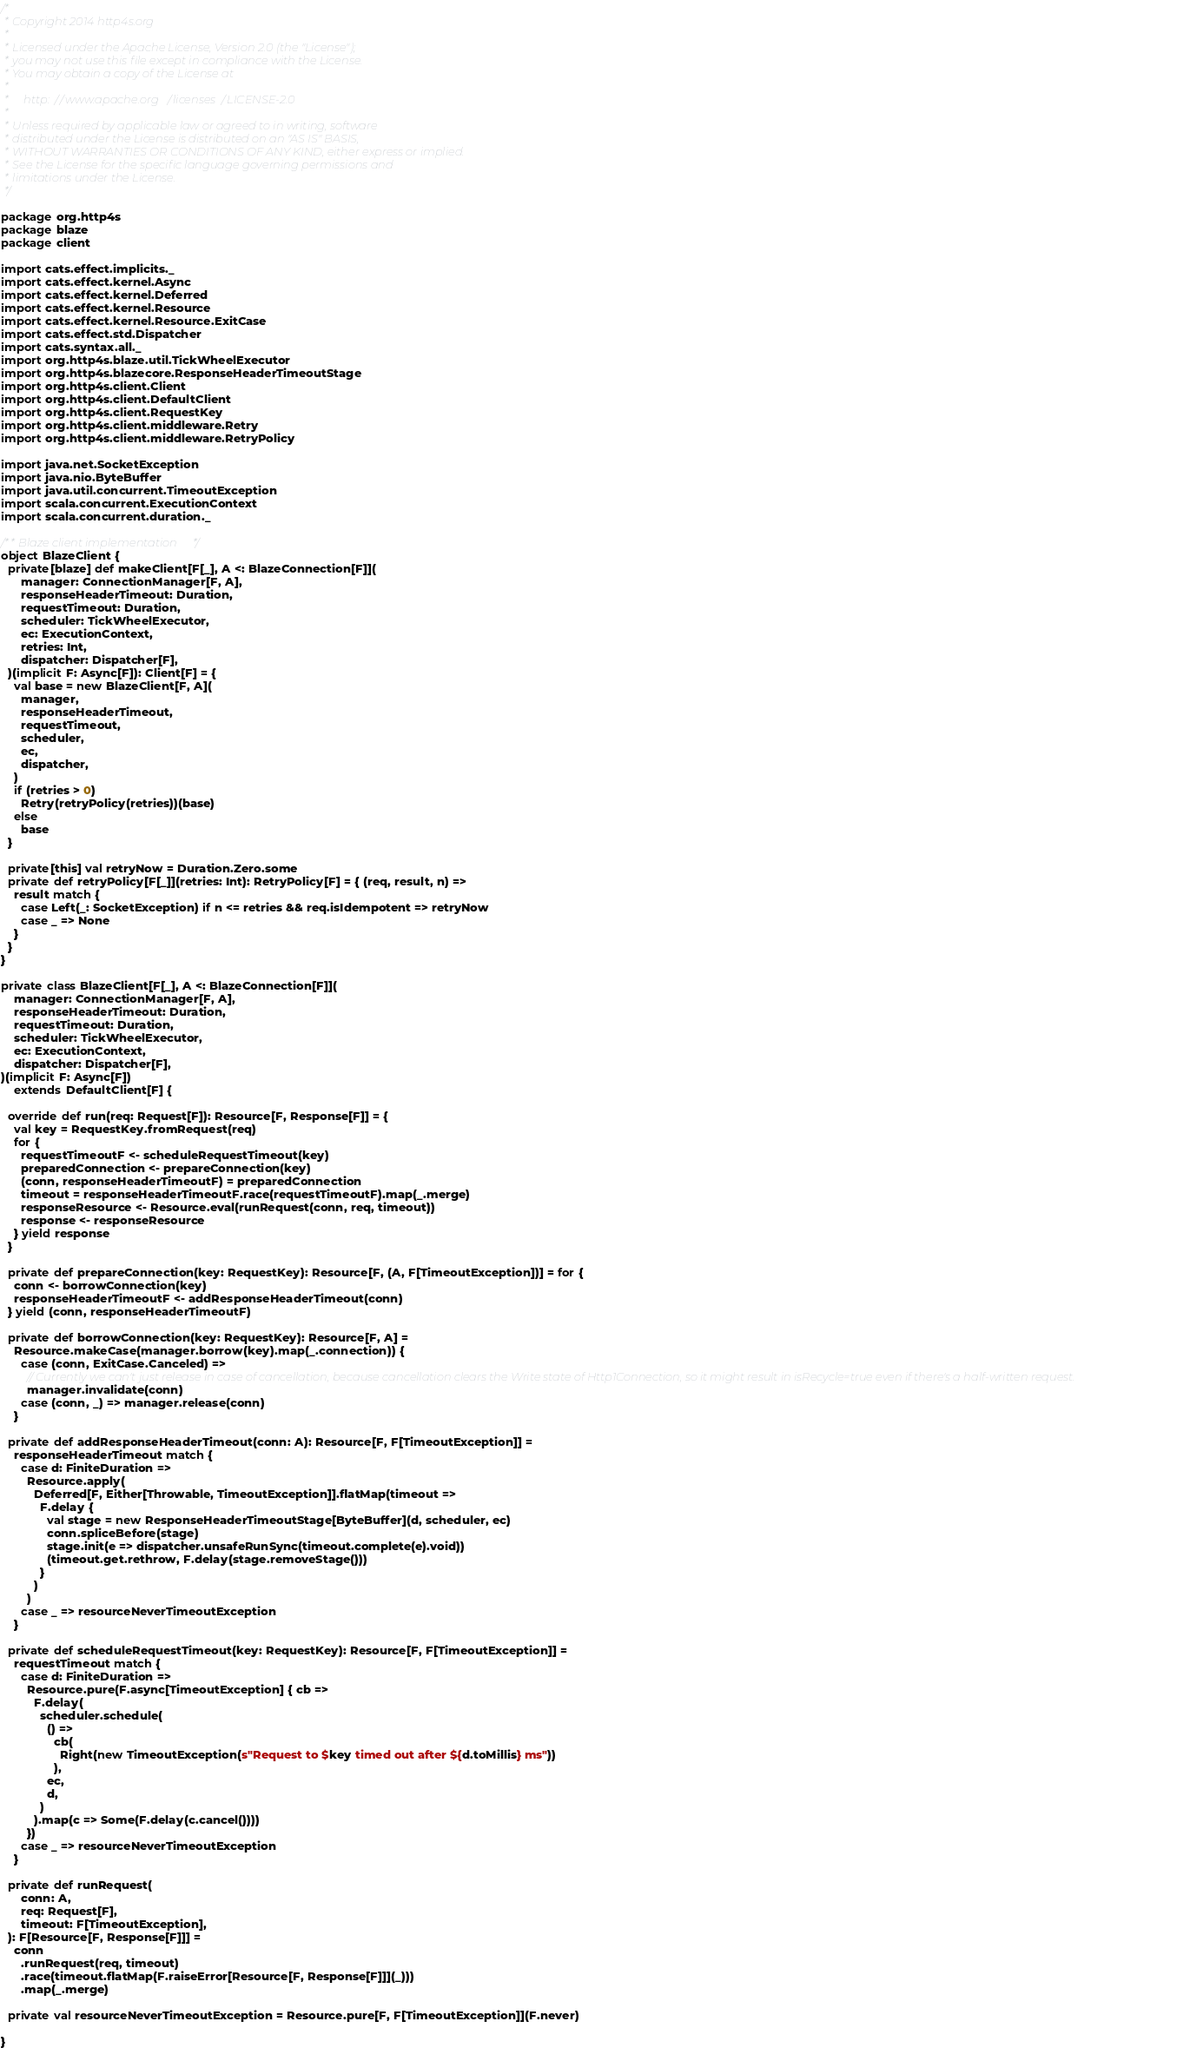Convert code to text. <code><loc_0><loc_0><loc_500><loc_500><_Scala_>/*
 * Copyright 2014 http4s.org
 *
 * Licensed under the Apache License, Version 2.0 (the "License");
 * you may not use this file except in compliance with the License.
 * You may obtain a copy of the License at
 *
 *     http://www.apache.org/licenses/LICENSE-2.0
 *
 * Unless required by applicable law or agreed to in writing, software
 * distributed under the License is distributed on an "AS IS" BASIS,
 * WITHOUT WARRANTIES OR CONDITIONS OF ANY KIND, either express or implied.
 * See the License for the specific language governing permissions and
 * limitations under the License.
 */

package org.http4s
package blaze
package client

import cats.effect.implicits._
import cats.effect.kernel.Async
import cats.effect.kernel.Deferred
import cats.effect.kernel.Resource
import cats.effect.kernel.Resource.ExitCase
import cats.effect.std.Dispatcher
import cats.syntax.all._
import org.http4s.blaze.util.TickWheelExecutor
import org.http4s.blazecore.ResponseHeaderTimeoutStage
import org.http4s.client.Client
import org.http4s.client.DefaultClient
import org.http4s.client.RequestKey
import org.http4s.client.middleware.Retry
import org.http4s.client.middleware.RetryPolicy

import java.net.SocketException
import java.nio.ByteBuffer
import java.util.concurrent.TimeoutException
import scala.concurrent.ExecutionContext
import scala.concurrent.duration._

/** Blaze client implementation */
object BlazeClient {
  private[blaze] def makeClient[F[_], A <: BlazeConnection[F]](
      manager: ConnectionManager[F, A],
      responseHeaderTimeout: Duration,
      requestTimeout: Duration,
      scheduler: TickWheelExecutor,
      ec: ExecutionContext,
      retries: Int,
      dispatcher: Dispatcher[F],
  )(implicit F: Async[F]): Client[F] = {
    val base = new BlazeClient[F, A](
      manager,
      responseHeaderTimeout,
      requestTimeout,
      scheduler,
      ec,
      dispatcher,
    )
    if (retries > 0)
      Retry(retryPolicy(retries))(base)
    else
      base
  }

  private[this] val retryNow = Duration.Zero.some
  private def retryPolicy[F[_]](retries: Int): RetryPolicy[F] = { (req, result, n) =>
    result match {
      case Left(_: SocketException) if n <= retries && req.isIdempotent => retryNow
      case _ => None
    }
  }
}

private class BlazeClient[F[_], A <: BlazeConnection[F]](
    manager: ConnectionManager[F, A],
    responseHeaderTimeout: Duration,
    requestTimeout: Duration,
    scheduler: TickWheelExecutor,
    ec: ExecutionContext,
    dispatcher: Dispatcher[F],
)(implicit F: Async[F])
    extends DefaultClient[F] {

  override def run(req: Request[F]): Resource[F, Response[F]] = {
    val key = RequestKey.fromRequest(req)
    for {
      requestTimeoutF <- scheduleRequestTimeout(key)
      preparedConnection <- prepareConnection(key)
      (conn, responseHeaderTimeoutF) = preparedConnection
      timeout = responseHeaderTimeoutF.race(requestTimeoutF).map(_.merge)
      responseResource <- Resource.eval(runRequest(conn, req, timeout))
      response <- responseResource
    } yield response
  }

  private def prepareConnection(key: RequestKey): Resource[F, (A, F[TimeoutException])] = for {
    conn <- borrowConnection(key)
    responseHeaderTimeoutF <- addResponseHeaderTimeout(conn)
  } yield (conn, responseHeaderTimeoutF)

  private def borrowConnection(key: RequestKey): Resource[F, A] =
    Resource.makeCase(manager.borrow(key).map(_.connection)) {
      case (conn, ExitCase.Canceled) =>
        // Currently we can't just release in case of cancellation, because cancellation clears the Write state of Http1Connection, so it might result in isRecycle=true even if there's a half-written request.
        manager.invalidate(conn)
      case (conn, _) => manager.release(conn)
    }

  private def addResponseHeaderTimeout(conn: A): Resource[F, F[TimeoutException]] =
    responseHeaderTimeout match {
      case d: FiniteDuration =>
        Resource.apply(
          Deferred[F, Either[Throwable, TimeoutException]].flatMap(timeout =>
            F.delay {
              val stage = new ResponseHeaderTimeoutStage[ByteBuffer](d, scheduler, ec)
              conn.spliceBefore(stage)
              stage.init(e => dispatcher.unsafeRunSync(timeout.complete(e).void))
              (timeout.get.rethrow, F.delay(stage.removeStage()))
            }
          )
        )
      case _ => resourceNeverTimeoutException
    }

  private def scheduleRequestTimeout(key: RequestKey): Resource[F, F[TimeoutException]] =
    requestTimeout match {
      case d: FiniteDuration =>
        Resource.pure(F.async[TimeoutException] { cb =>
          F.delay(
            scheduler.schedule(
              () =>
                cb(
                  Right(new TimeoutException(s"Request to $key timed out after ${d.toMillis} ms"))
                ),
              ec,
              d,
            )
          ).map(c => Some(F.delay(c.cancel())))
        })
      case _ => resourceNeverTimeoutException
    }

  private def runRequest(
      conn: A,
      req: Request[F],
      timeout: F[TimeoutException],
  ): F[Resource[F, Response[F]]] =
    conn
      .runRequest(req, timeout)
      .race(timeout.flatMap(F.raiseError[Resource[F, Response[F]]](_)))
      .map(_.merge)

  private val resourceNeverTimeoutException = Resource.pure[F, F[TimeoutException]](F.never)

}
</code> 